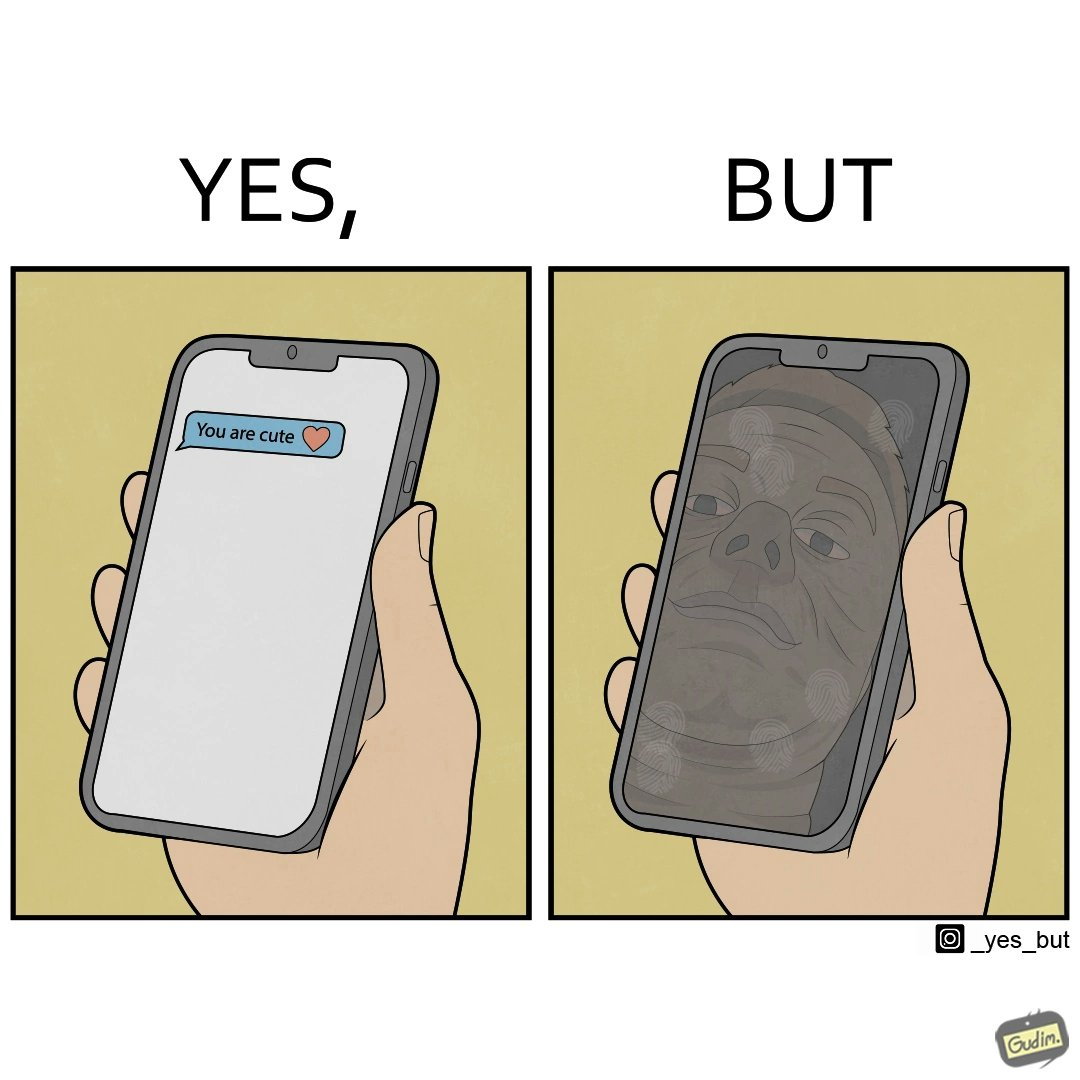What do you see in each half of this image? In the left part of the image: someone holding a phone and the screen shows a message from someone as "You are cute" In the right part of the image: a person, probably a man, viewing at his face in the phone screen after turned off, the phone screen has touch marks on it 